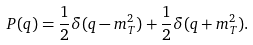Convert formula to latex. <formula><loc_0><loc_0><loc_500><loc_500>P ( q ) = \frac { 1 } { 2 } \delta ( q - m _ { T } ^ { 2 } ) + \frac { 1 } { 2 } \delta ( q + m _ { T } ^ { 2 } ) .</formula> 